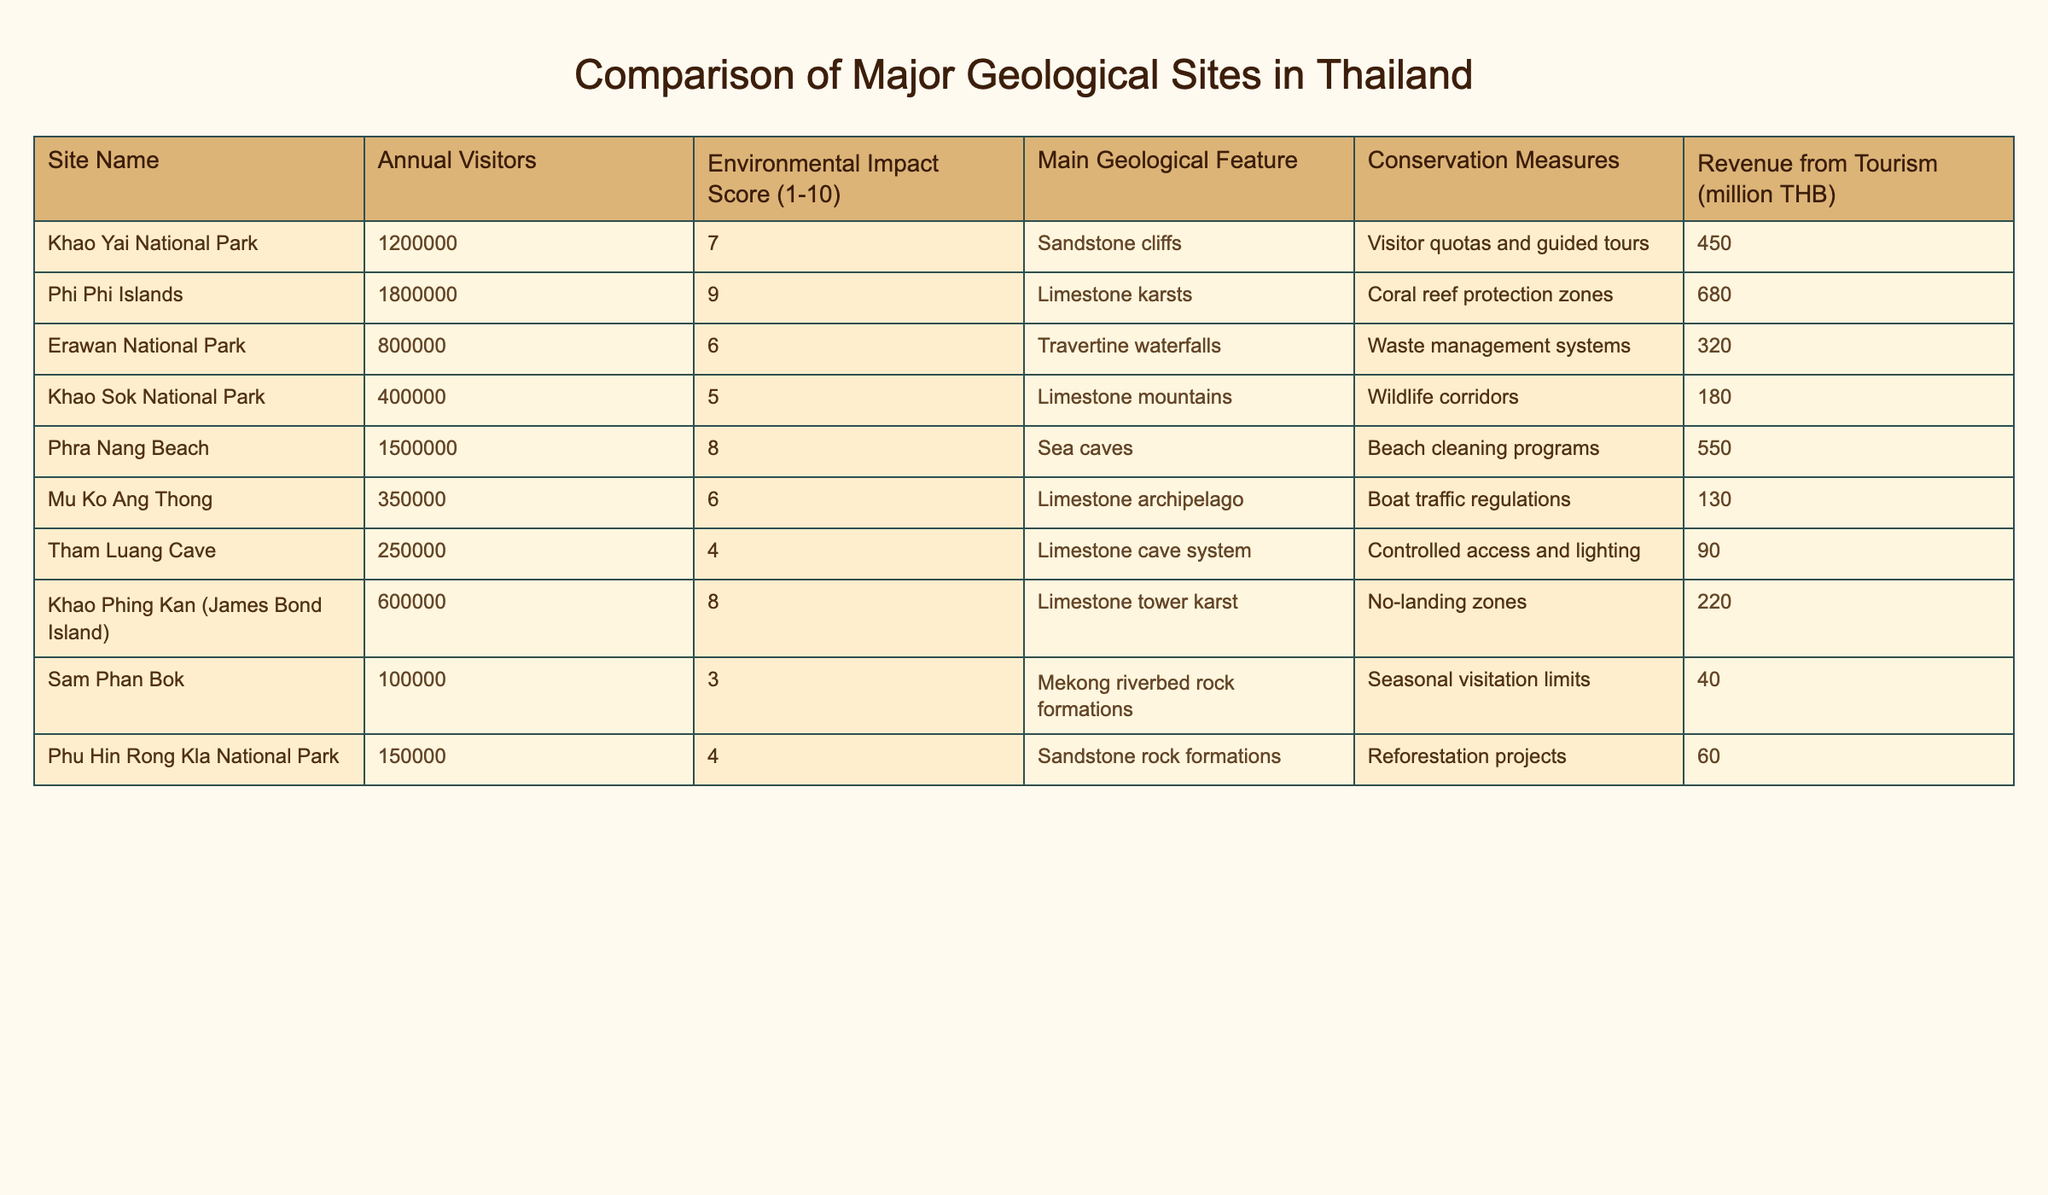What is the annual visitor number for Erawan National Park? The table lists Erawan National Park in the first column under "Site Name" and shows 800000 in the "Annual Visitors" column next to it.
Answer: 800000 Which site has the highest environmental impact score? By scanning the "Environmental Impact Score" column, Phi Phi Islands is shown to have the highest score of 9.
Answer: Phi Phi Islands What is the total revenue from tourism for Khao Yai National Park and Phra Nang Beach combined? For Khao Yai National Park, the revenue is 450 million THB and for Phra Nang Beach, it is 550 million THB. Adding these values gives 450 + 550 = 1000 million THB.
Answer: 1000 million THB Is the environmental impact score of Sam Phan Bok lower than that of Khao Sok National Park? The table shows Sam Phan Bok with an environmental impact score of 3 and Khao Sok National Park with a score of 5. Since 3 is less than 5, the statement is true.
Answer: Yes What is the average annual visitor number for the sites listed with limestone features? The limestone feature sites are Phi Phi Islands (1800000), Khao Sok National Park (400000), Mu Ko Ang Thong (350000), Khao Phing Kan (James Bond Island) (600000), and Tham Luang Cave (250000). First, we sum these visitor numbers: 1800000 + 400000 + 350000 + 600000 + 250000 = 3360000. Then, we count the number of sites, which is 5, and calculate the average: 3360000 / 5 = 672000.
Answer: 672000 Which geological site has the least annual visitors? Scanning the "Annual Visitors" column, Sam Phan Bok has the lowest value listed, which is 100000.
Answer: Sam Phan Bok How many sites have an environmental impact score of 5 or lower? From the "Environmental Impact Score" column, the sites with scores of 5 or lower are Khao Sok National Park (5), Tham Luang Cave (4), and Sam Phan Bok (3). That totals 3 sites.
Answer: 3 sites What is the difference in revenue from tourism between the Phi Phi Islands and Khao Phing Kan? The revenue from Phi Phi Islands is 680 million THB, and Khao Phing Kan is 220 million THB. The difference is 680 - 220 = 460 million THB.
Answer: 460 million THB Is Khao Yai National Park among the top three sites in terms of annual visitors? Khao Yai National Park has 1200000 visitors, compared to the highest (Phi Phi Islands at 1800000), second highest (Phra Nang Beach at 1500000), and Khao Yai falls at third place in visitor numbers. Hence, it is among the top three.
Answer: Yes 